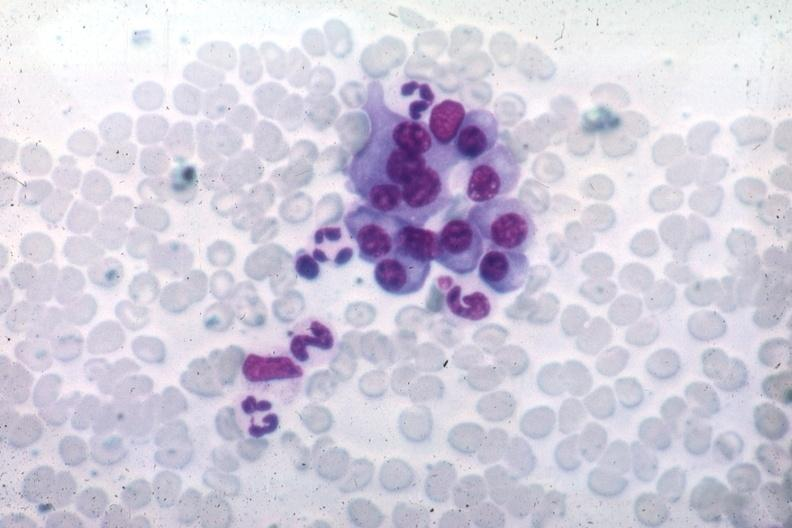what is this image shows wrights typical differentiated?
Answer the question using a single word or phrase. Plasma cells source unknown 